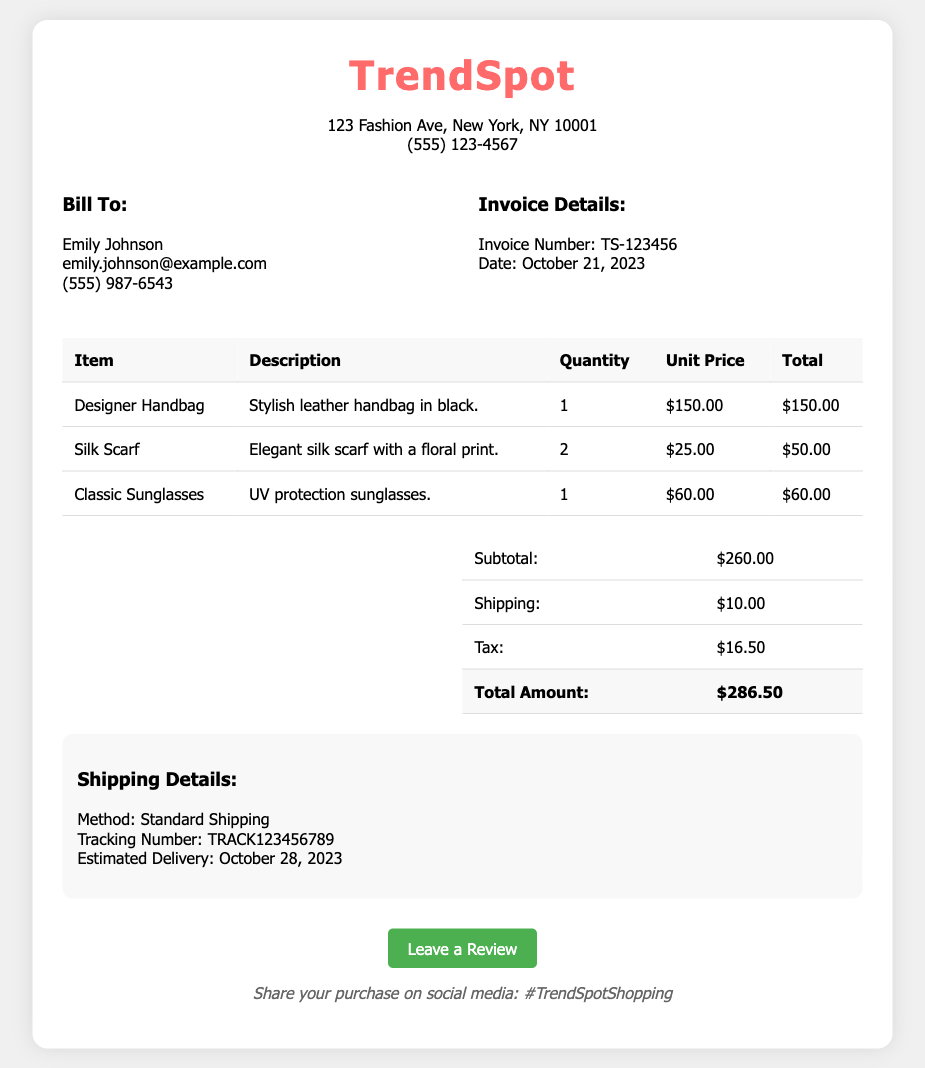What is the invoice number? The invoice number is explicitly listed under the invoice details section of the document.
Answer: TS-123456 Who is the bill to? The 'Bill To' section clearly states the name of the customer.
Answer: Emily Johnson What is the total amount? The total amount is calculated as the sum of the subtotal, shipping, and tax in the summary section.
Answer: $286.50 What is the shipping method? The shipping method is mentioned in the shipping details section of the document.
Answer: Standard Shipping How many Silk Scarves were purchased? The quantity of Silk Scarves is listed in the itemized table of the document.
Answer: 2 When is the estimated delivery date? The estimated delivery date is specified in the shipping details section.
Answer: October 28, 2023 What is the total quantity of items ordered? The total quantity is the sum of the quantities listed in the itemized table.
Answer: 4 What link is provided for leaving a review? The document includes a specific link where the customer can leave their review.
Answer: https://www.trendspot.com/reviews What is the tracking number for the shipment? The tracking number is provided in the shipping details section of the document.
Answer: TRACK123456789 